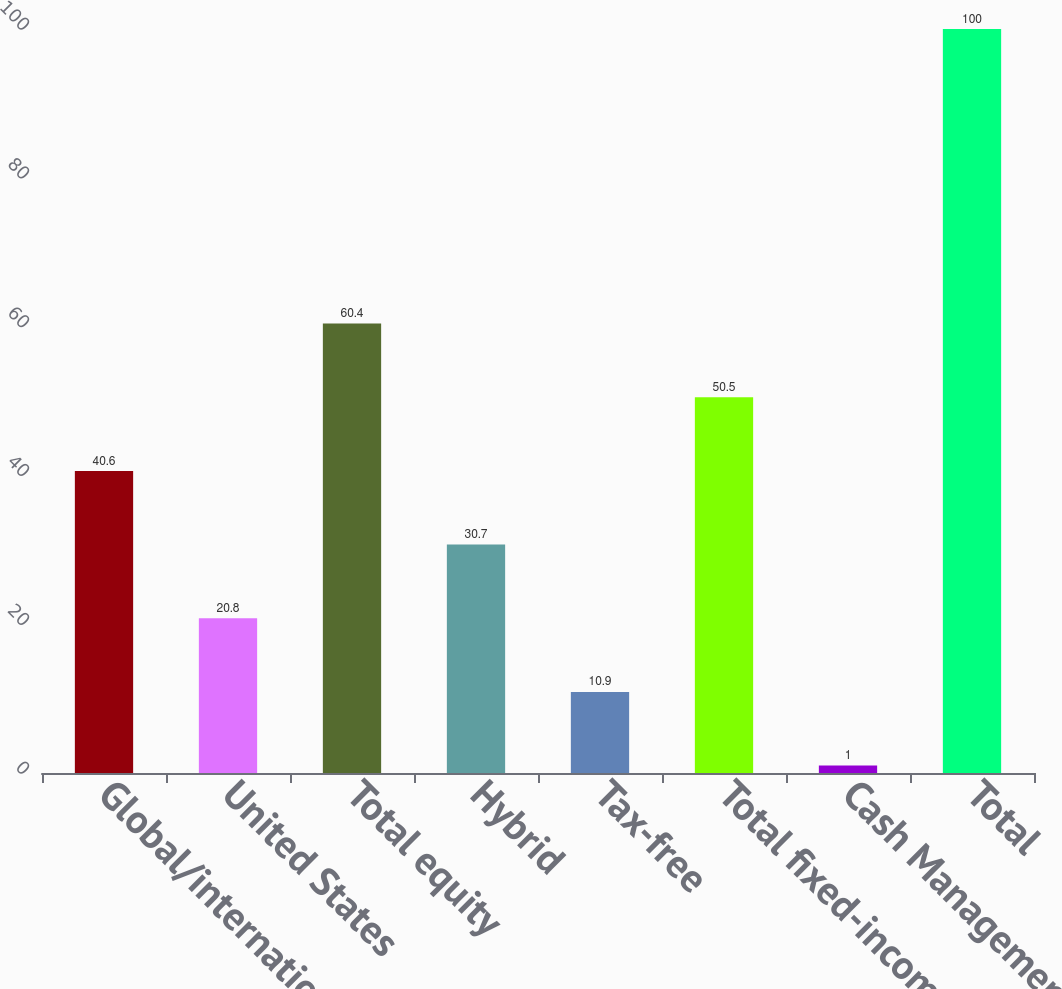Convert chart. <chart><loc_0><loc_0><loc_500><loc_500><bar_chart><fcel>Global/international<fcel>United States<fcel>Total equity<fcel>Hybrid<fcel>Tax-free<fcel>Total fixed-income<fcel>Cash Management<fcel>Total<nl><fcel>40.6<fcel>20.8<fcel>60.4<fcel>30.7<fcel>10.9<fcel>50.5<fcel>1<fcel>100<nl></chart> 